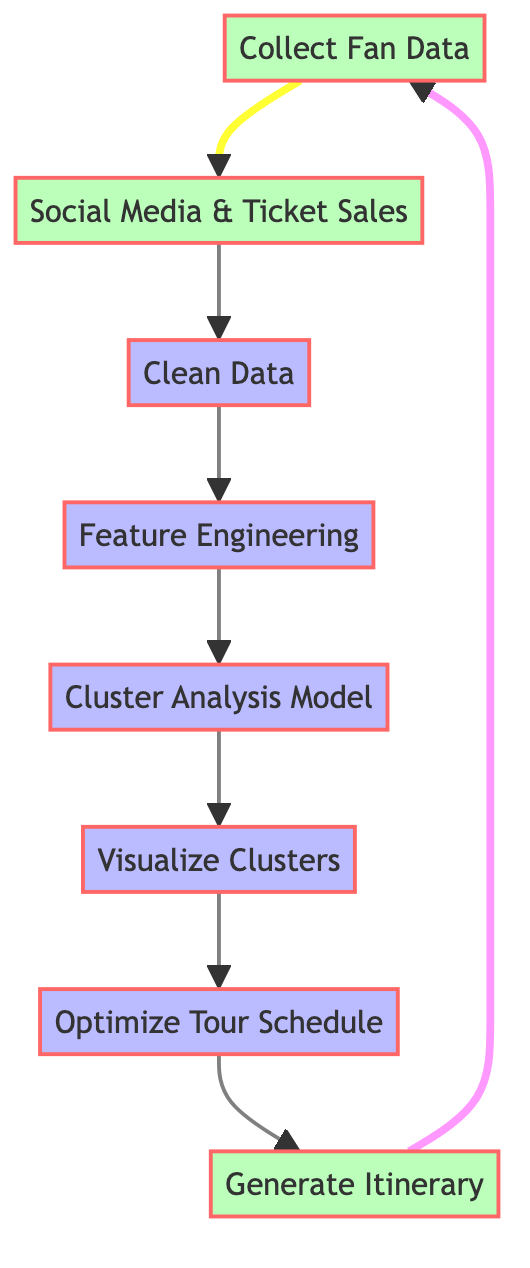What is the first step in the diagram? The diagram starts with the node labeled "Collect Fan Data," which indicates that this is the initial step of the process.
Answer: Collect Fan Data How many main processing nodes are presented in the diagram? The processing nodes are "Clean Data," "Feature Engineering," "Cluster Analysis Model," "Visualize Clusters," and "Optimize Tour Schedule," totaling five main processing nodes in the diagram.
Answer: Five Which node follows the "Cluster Analysis Model"? The node that directly follows "Cluster Analysis Model" is "Visualize Clusters," indicating that after performing cluster analysis, the next action is to visualize the clusters.
Answer: Visualize Clusters How does the "Optimize Tour Schedule" node relate to the "Generate Itinerary" node? The relationship shows that "Optimize Tour Schedule" directly feeds into "Generate Itinerary," meaning the itinerary is created based on the optimized tour schedule.
Answer: Directly feeds into If one were to trace the flow backward from "Generate Itinerary," which node would be encountered first? Tracing backward from "Generate Itinerary," the first node encountered would be "Optimize Tour Schedule,” indicating the processes that lead into itinerary generation.
Answer: Optimize Tour Schedule What is the last action in the iterative process of the diagram? The last action mentioned in the iterative process is "Generate Itinerary," which concludes the steps before returning to "Collect Fan Data” to repeat the cycle.
Answer: Generate Itinerary How many edges connect the data nodes in the diagram? The data nodes are "Collect Fan Data," "Social Media & Ticket Sales," and "Generate Itinerary." Edges connect these three nodes; there are a total of three edges connecting the data nodes.
Answer: Three What color represents the data nodes in the diagram? The data nodes are represented in green (bfb), indicating that the color scheme consistently categorizes data-related steps.
Answer: Green 